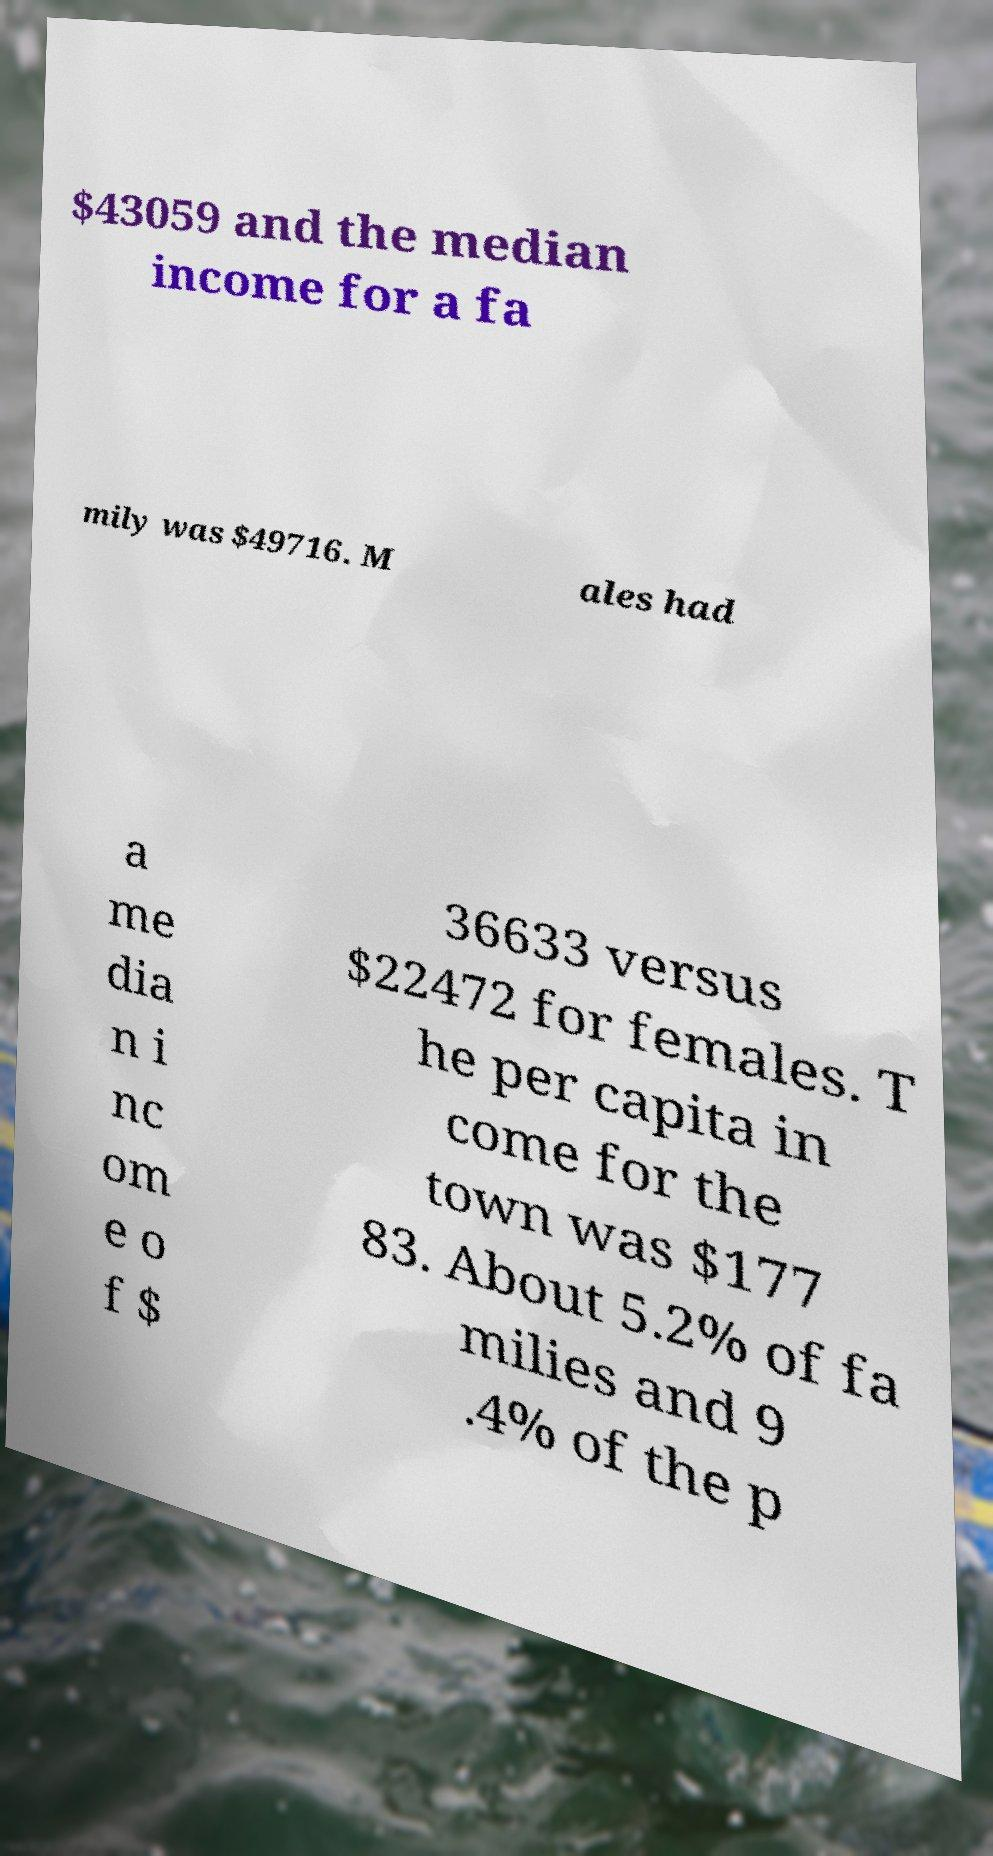I need the written content from this picture converted into text. Can you do that? $43059 and the median income for a fa mily was $49716. M ales had a me dia n i nc om e o f $ 36633 versus $22472 for females. T he per capita in come for the town was $177 83. About 5.2% of fa milies and 9 .4% of the p 